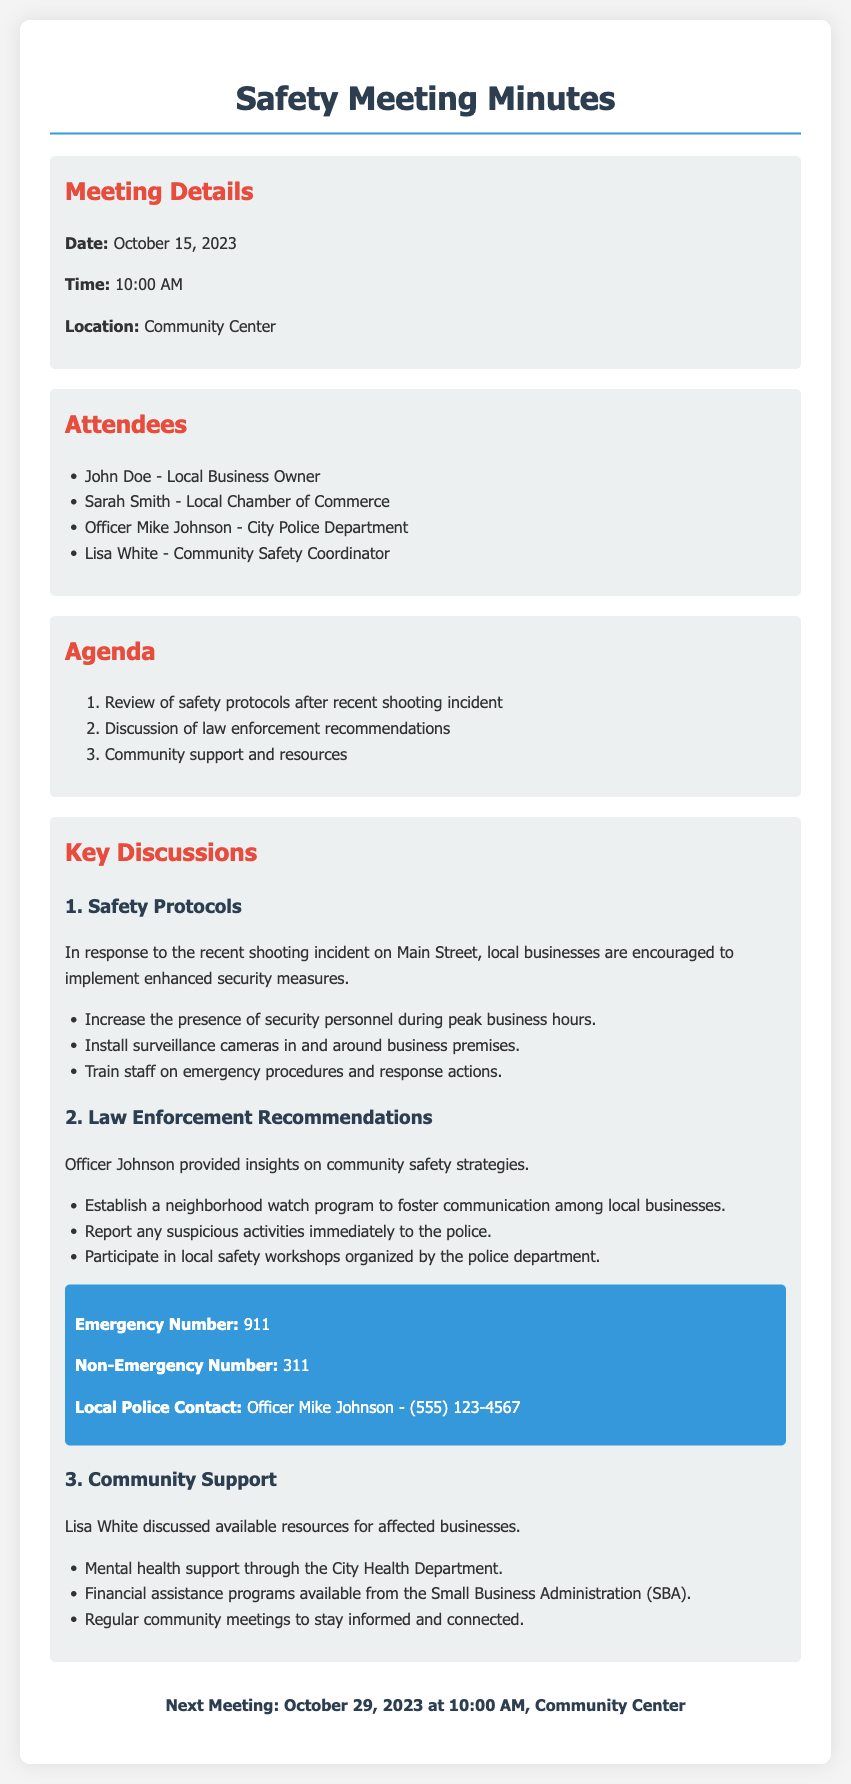what is the date of the meeting? The date is explicitly stated in the meeting details section of the document.
Answer: October 15, 2023 who attended the meeting representing the City Police Department? This information can be found in the attendees list of the document.
Answer: Officer Mike Johnson what was the main topic of the second agenda item? This can be inferred from the agenda listed in the document.
Answer: Discussion of law enforcement recommendations what security measure involves staff training? This is specified under the safety protocols discussed in the key discussions section.
Answer: Train staff on emergency procedures and response actions what type of program is recommended to enhance community safety? The information is found in the law enforcement recommendations outlined in the document.
Answer: Neighborhood watch program how often will community meetings occur to stay informed? This is implied in the community support section regarding regular meetings for connection.
Answer: Regularly what is the next meeting date mentioned? This detail is stated at the end of the document as the time and location for the future meeting.
Answer: October 29, 2023 which organization was mentioned for providing financial assistance? The source of financial assistance is highlighted in the community support section of the document.
Answer: Small Business Administration (SBA) 